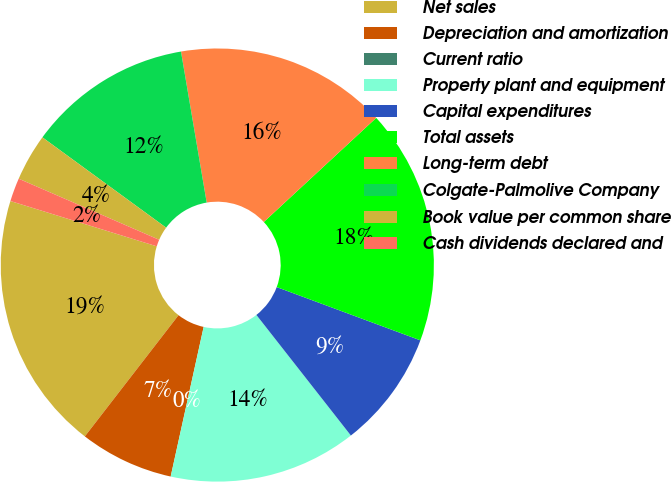<chart> <loc_0><loc_0><loc_500><loc_500><pie_chart><fcel>Net sales<fcel>Depreciation and amortization<fcel>Current ratio<fcel>Property plant and equipment<fcel>Capital expenditures<fcel>Total assets<fcel>Long-term debt<fcel>Colgate-Palmolive Company<fcel>Book value per common share<fcel>Cash dividends declared and<nl><fcel>19.3%<fcel>7.02%<fcel>0.0%<fcel>14.03%<fcel>8.77%<fcel>17.54%<fcel>15.79%<fcel>12.28%<fcel>3.51%<fcel>1.75%<nl></chart> 